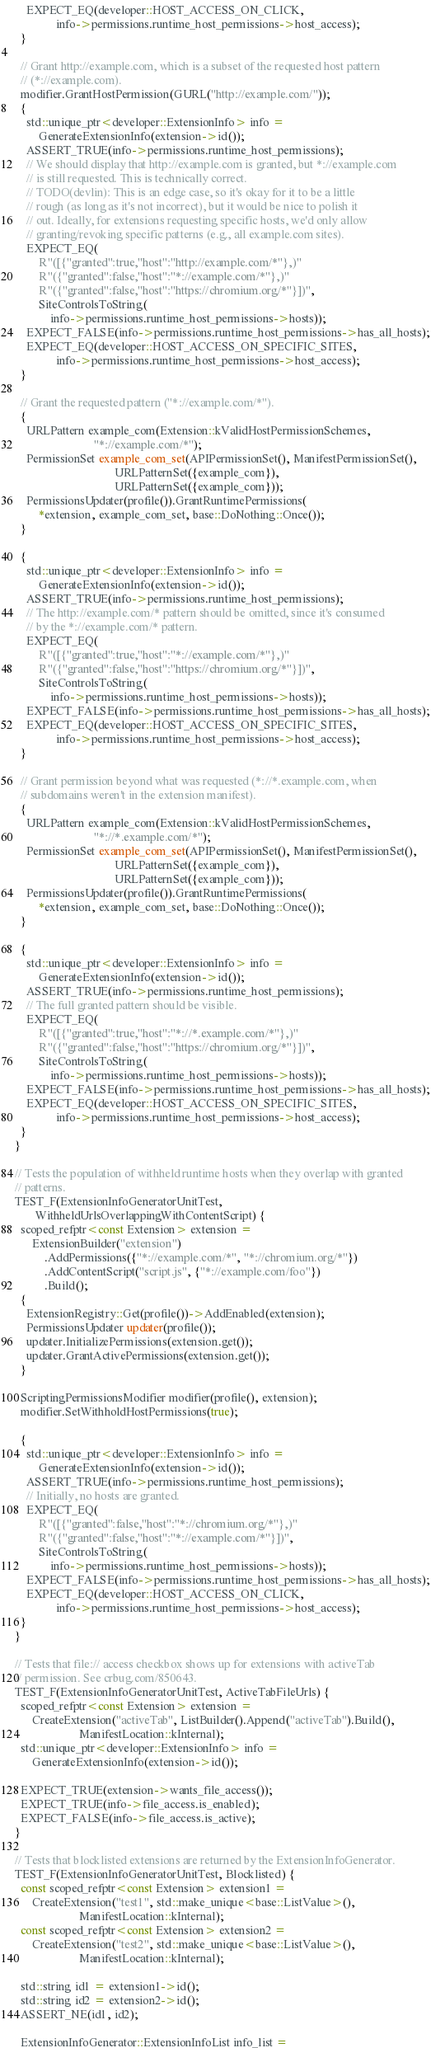Convert code to text. <code><loc_0><loc_0><loc_500><loc_500><_C++_>    EXPECT_EQ(developer::HOST_ACCESS_ON_CLICK,
              info->permissions.runtime_host_permissions->host_access);
  }

  // Grant http://example.com, which is a subset of the requested host pattern
  // (*://example.com).
  modifier.GrantHostPermission(GURL("http://example.com/"));
  {
    std::unique_ptr<developer::ExtensionInfo> info =
        GenerateExtensionInfo(extension->id());
    ASSERT_TRUE(info->permissions.runtime_host_permissions);
    // We should display that http://example.com is granted, but *://example.com
    // is still requested. This is technically correct.
    // TODO(devlin): This is an edge case, so it's okay for it to be a little
    // rough (as long as it's not incorrect), but it would be nice to polish it
    // out. Ideally, for extensions requesting specific hosts, we'd only allow
    // granting/revoking specific patterns (e.g., all example.com sites).
    EXPECT_EQ(
        R"([{"granted":true,"host":"http://example.com/*"},)"
        R"({"granted":false,"host":"*://example.com/*"},)"
        R"({"granted":false,"host":"https://chromium.org/*"}])",
        SiteControlsToString(
            info->permissions.runtime_host_permissions->hosts));
    EXPECT_FALSE(info->permissions.runtime_host_permissions->has_all_hosts);
    EXPECT_EQ(developer::HOST_ACCESS_ON_SPECIFIC_SITES,
              info->permissions.runtime_host_permissions->host_access);
  }

  // Grant the requested pattern ("*://example.com/*").
  {
    URLPattern example_com(Extension::kValidHostPermissionSchemes,
                           "*://example.com/*");
    PermissionSet example_com_set(APIPermissionSet(), ManifestPermissionSet(),
                                  URLPatternSet({example_com}),
                                  URLPatternSet({example_com}));
    PermissionsUpdater(profile()).GrantRuntimePermissions(
        *extension, example_com_set, base::DoNothing::Once());
  }

  {
    std::unique_ptr<developer::ExtensionInfo> info =
        GenerateExtensionInfo(extension->id());
    ASSERT_TRUE(info->permissions.runtime_host_permissions);
    // The http://example.com/* pattern should be omitted, since it's consumed
    // by the *://example.com/* pattern.
    EXPECT_EQ(
        R"([{"granted":true,"host":"*://example.com/*"},)"
        R"({"granted":false,"host":"https://chromium.org/*"}])",
        SiteControlsToString(
            info->permissions.runtime_host_permissions->hosts));
    EXPECT_FALSE(info->permissions.runtime_host_permissions->has_all_hosts);
    EXPECT_EQ(developer::HOST_ACCESS_ON_SPECIFIC_SITES,
              info->permissions.runtime_host_permissions->host_access);
  }

  // Grant permission beyond what was requested (*://*.example.com, when
  // subdomains weren't in the extension manifest).
  {
    URLPattern example_com(Extension::kValidHostPermissionSchemes,
                           "*://*.example.com/*");
    PermissionSet example_com_set(APIPermissionSet(), ManifestPermissionSet(),
                                  URLPatternSet({example_com}),
                                  URLPatternSet({example_com}));
    PermissionsUpdater(profile()).GrantRuntimePermissions(
        *extension, example_com_set, base::DoNothing::Once());
  }

  {
    std::unique_ptr<developer::ExtensionInfo> info =
        GenerateExtensionInfo(extension->id());
    ASSERT_TRUE(info->permissions.runtime_host_permissions);
    // The full granted pattern should be visible.
    EXPECT_EQ(
        R"([{"granted":true,"host":"*://*.example.com/*"},)"
        R"({"granted":false,"host":"https://chromium.org/*"}])",
        SiteControlsToString(
            info->permissions.runtime_host_permissions->hosts));
    EXPECT_FALSE(info->permissions.runtime_host_permissions->has_all_hosts);
    EXPECT_EQ(developer::HOST_ACCESS_ON_SPECIFIC_SITES,
              info->permissions.runtime_host_permissions->host_access);
  }
}

// Tests the population of withheld runtime hosts when they overlap with granted
// patterns.
TEST_F(ExtensionInfoGeneratorUnitTest,
       WithheldUrlsOverlappingWithContentScript) {
  scoped_refptr<const Extension> extension =
      ExtensionBuilder("extension")
          .AddPermissions({"*://example.com/*", "*://chromium.org/*"})
          .AddContentScript("script.js", {"*://example.com/foo"})
          .Build();
  {
    ExtensionRegistry::Get(profile())->AddEnabled(extension);
    PermissionsUpdater updater(profile());
    updater.InitializePermissions(extension.get());
    updater.GrantActivePermissions(extension.get());
  }

  ScriptingPermissionsModifier modifier(profile(), extension);
  modifier.SetWithholdHostPermissions(true);

  {
    std::unique_ptr<developer::ExtensionInfo> info =
        GenerateExtensionInfo(extension->id());
    ASSERT_TRUE(info->permissions.runtime_host_permissions);
    // Initially, no hosts are granted.
    EXPECT_EQ(
        R"([{"granted":false,"host":"*://chromium.org/*"},)"
        R"({"granted":false,"host":"*://example.com/*"}])",
        SiteControlsToString(
            info->permissions.runtime_host_permissions->hosts));
    EXPECT_FALSE(info->permissions.runtime_host_permissions->has_all_hosts);
    EXPECT_EQ(developer::HOST_ACCESS_ON_CLICK,
              info->permissions.runtime_host_permissions->host_access);
  }
}

// Tests that file:// access checkbox shows up for extensions with activeTab
// permission. See crbug.com/850643.
TEST_F(ExtensionInfoGeneratorUnitTest, ActiveTabFileUrls) {
  scoped_refptr<const Extension> extension =
      CreateExtension("activeTab", ListBuilder().Append("activeTab").Build(),
                      ManifestLocation::kInternal);
  std::unique_ptr<developer::ExtensionInfo> info =
      GenerateExtensionInfo(extension->id());

  EXPECT_TRUE(extension->wants_file_access());
  EXPECT_TRUE(info->file_access.is_enabled);
  EXPECT_FALSE(info->file_access.is_active);
}

// Tests that blocklisted extensions are returned by the ExtensionInfoGenerator.
TEST_F(ExtensionInfoGeneratorUnitTest, Blocklisted) {
  const scoped_refptr<const Extension> extension1 =
      CreateExtension("test1", std::make_unique<base::ListValue>(),
                      ManifestLocation::kInternal);
  const scoped_refptr<const Extension> extension2 =
      CreateExtension("test2", std::make_unique<base::ListValue>(),
                      ManifestLocation::kInternal);

  std::string id1 = extension1->id();
  std::string id2 = extension2->id();
  ASSERT_NE(id1, id2);

  ExtensionInfoGenerator::ExtensionInfoList info_list =</code> 